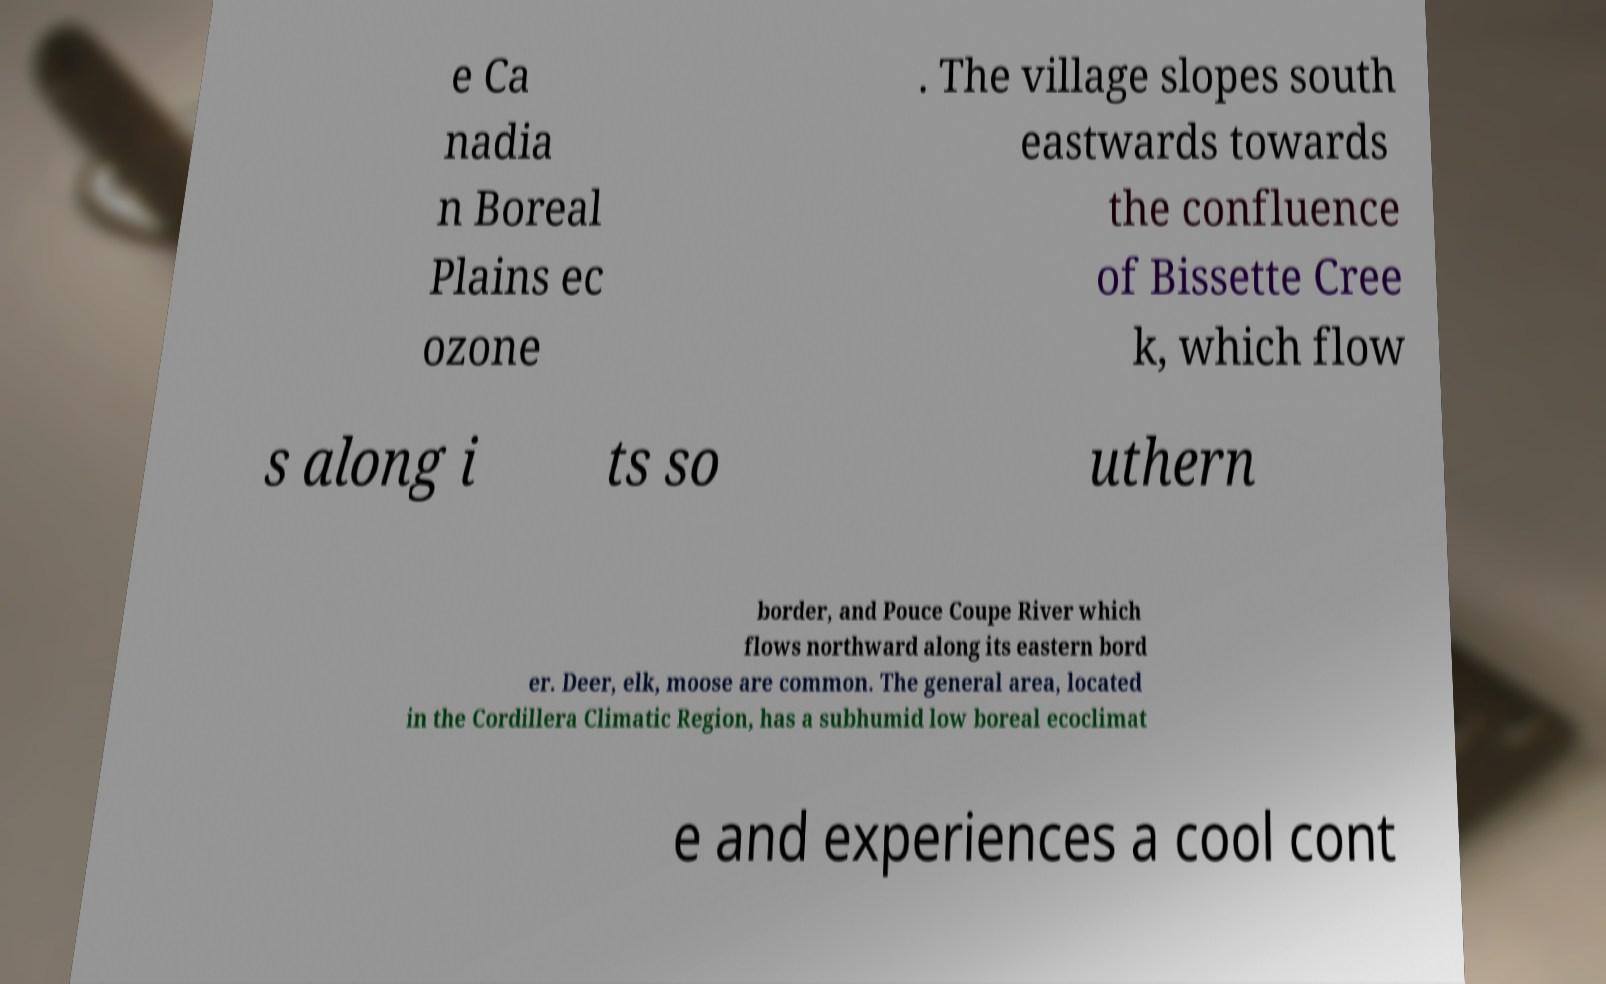Can you read and provide the text displayed in the image?This photo seems to have some interesting text. Can you extract and type it out for me? e Ca nadia n Boreal Plains ec ozone . The village slopes south eastwards towards the confluence of Bissette Cree k, which flow s along i ts so uthern border, and Pouce Coupe River which flows northward along its eastern bord er. Deer, elk, moose are common. The general area, located in the Cordillera Climatic Region, has a subhumid low boreal ecoclimat e and experiences a cool cont 